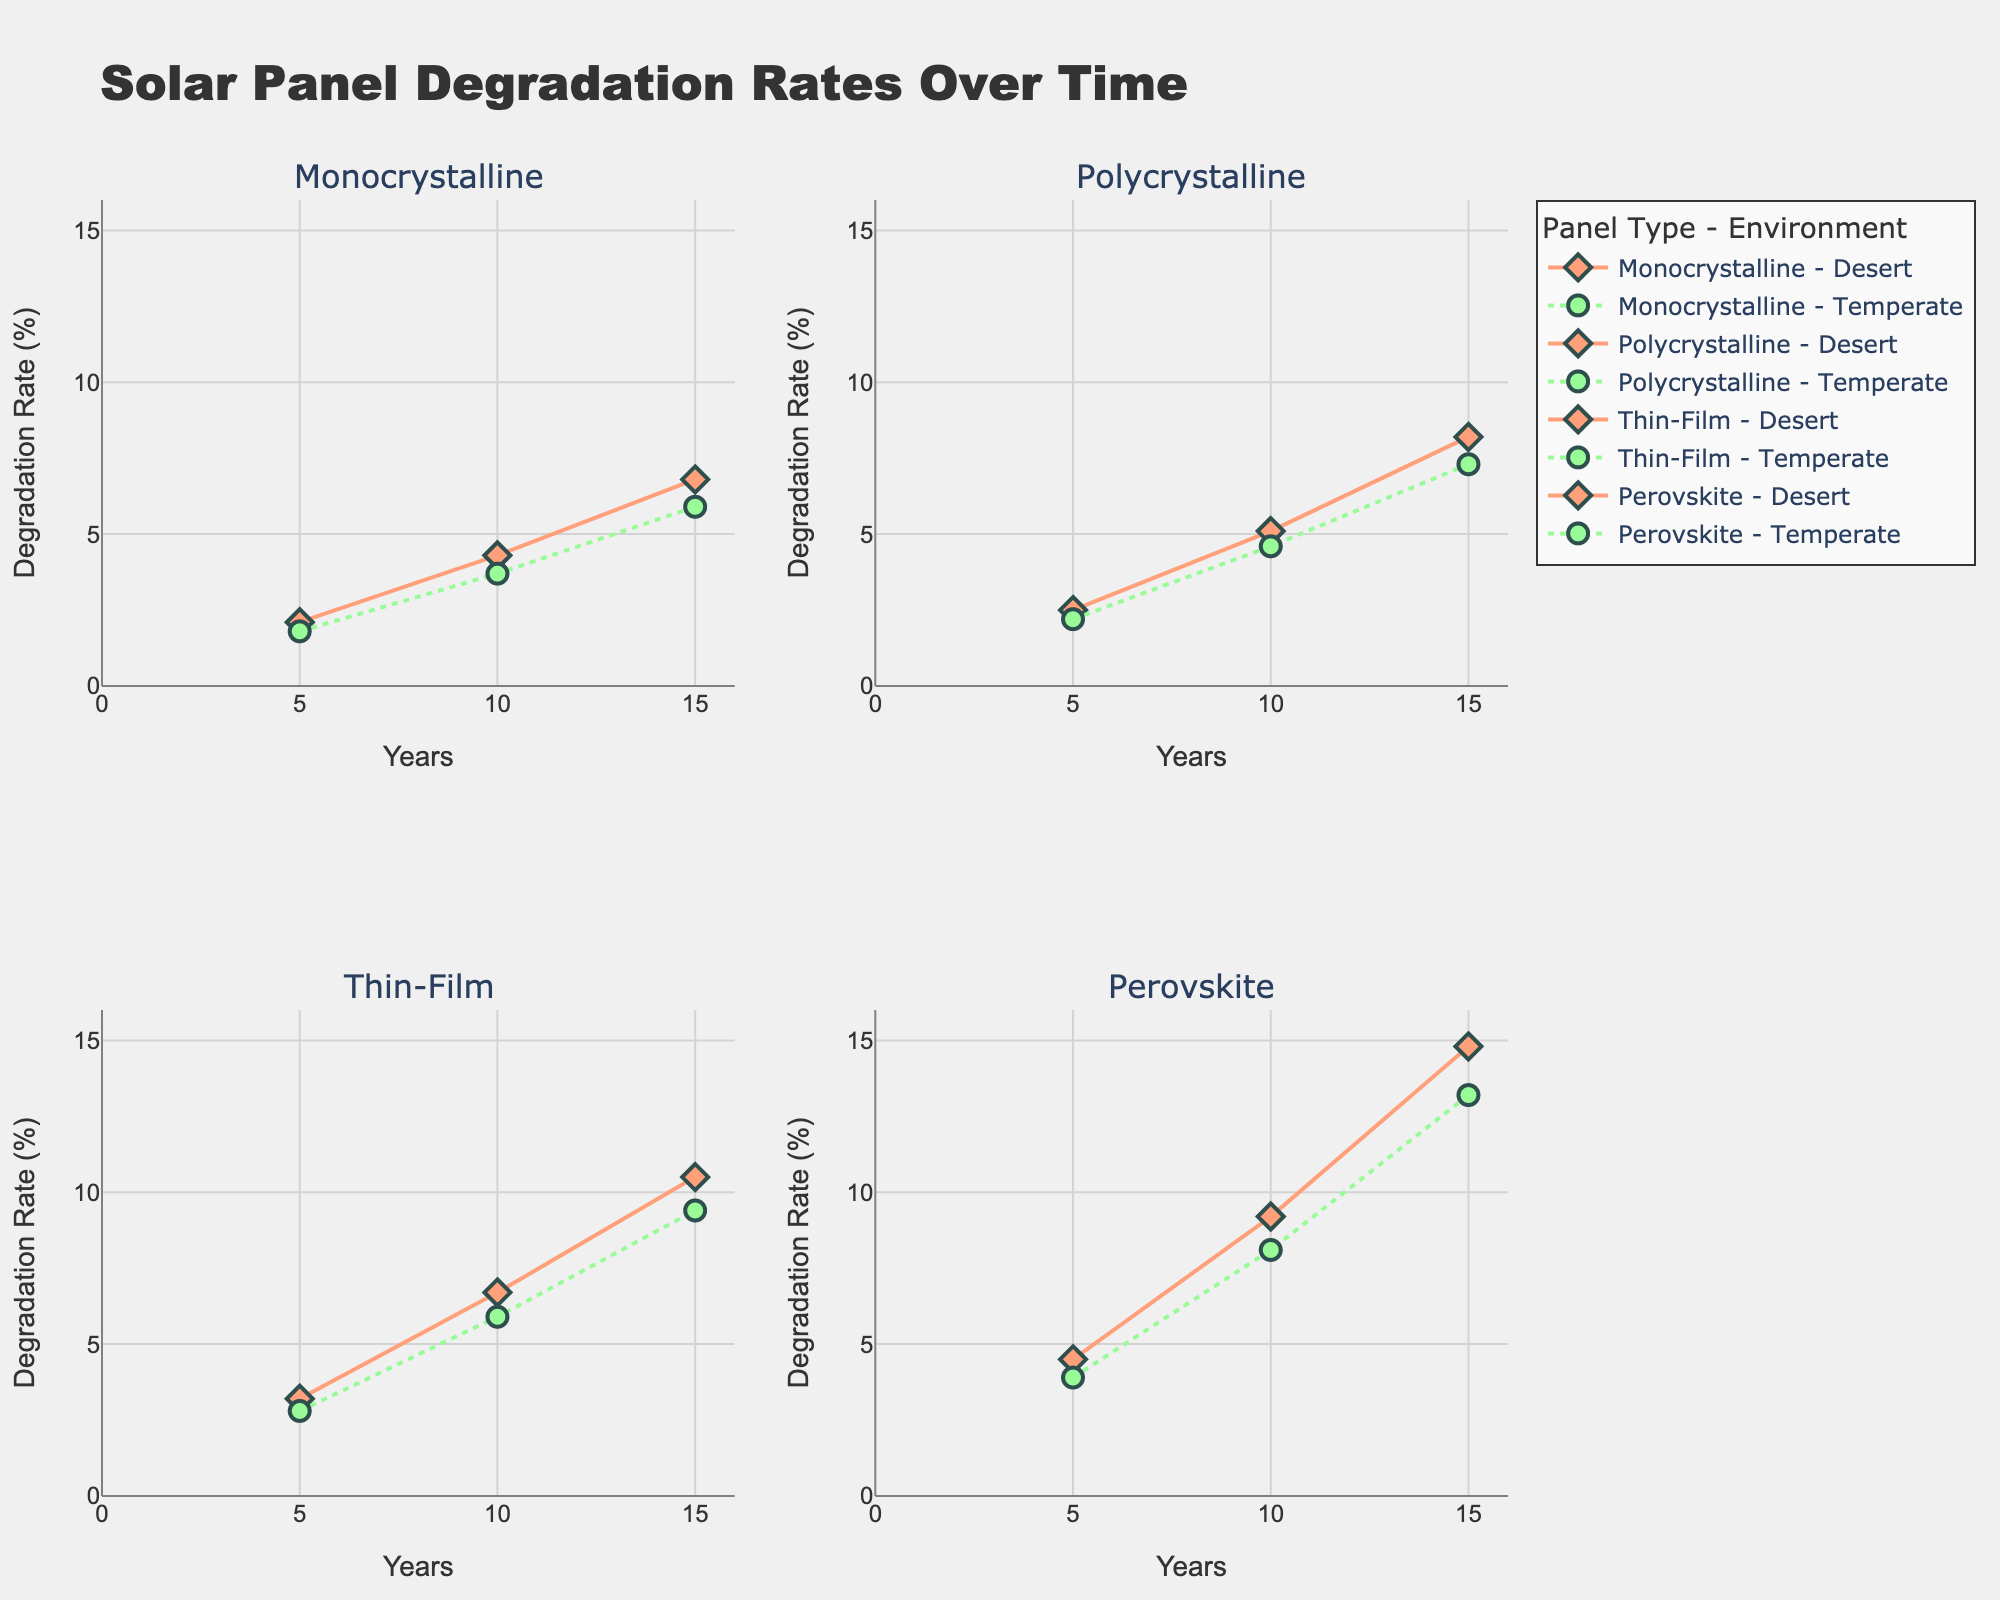What is the title of the figure? The title of the figure is displayed at the top of the plot, reading "Solar Panel Degradation Rates Over Time".
Answer: Solar Panel Degradation Rates Over Time How many types of solar panels are compared in the figure? There are four subplots within the figure, each titled with the name of a different solar panel type, implying there are four types compared: Monocrystalline, Polycrystalline, Thin-Film, and Perovskite.
Answer: Four Which environment shows a higher degradation rate for Thin-Film panels at the 10-year mark? Look at the Thin-Film subplot and compare the degradation rates for the Desert (in orange diamond markers) and Temperate (in green circle markers) for the 10-year mark. The Desert environment shows a higher rate of 6.7% compared to 5.9% in the Temperate environment.
Answer: Desert What is the degradation rate difference at the 15-year mark between Monocrystalline panels in Desert and Polycrystalline panels in Temperate environments? In their respective subplots, the degradation rates at the 15-year mark can be found: Monocrystalline in Desert is 6.8% and Polycrystalline in Temperate is 7.3%. Subtract the former from the latter to find the difference of 0.5%.
Answer: 0.5% What is the trend observed for Perovskite panels in both environments over time? Perovskite panels in both Desert and Temperate environments show an increasing trend over time in degradation rates. This is shown by the upward trends in both series of markers and lines within the Perovskite subplot.
Answer: Increasing How does the initial degradation rate (at the 5-year mark) of Monocrystalline panels in Temperate environments compare to Polycrystalline panels in Desert environments? Find and compare the degradation rates at the 5-year mark from their subplots: Monocrystalline in Temperate is 1.8% and Polycrystalline in Desert is 2.5%. The degradation rate of Polycrystalline in Desert is higher.
Answer: Polycrystalline in Desert is higher What is the average degradation rate for Thin-Film panels in Desert environments over the observed time periods? Sum the degradation rates of Thin-Film panels in Desert environments (3.2 + 6.7 + 10.5) and divide by the number of observations (3). The calculation yields (3.2 + 6.7 + 10.5)/3 = 6.8%.
Answer: 6.8% Do Perovskite panels degrade faster in Desert or Temperate environments at the 15-year mark? In the Perovskite subplot, compare the 15-year degradation rates. In Desert, it is 14.8%, and in Temperate, it is 13.2%. The Desert environment shows a faster degradation rate.
Answer: Desert Which panel type shows the least degradation in Temperate environments at the 10-year mark? In their respective subplots, examine the 10-year degradation rates in Temperate environments: Monocrystalline (3.7%), Polycrystalline (4.6%), Thin-Film (5.9%), and Perovskite (8.1%). Monocrystalline shows the least degradation.
Answer: Monocrystalline How does the degradation rate of Polycrystalline panels in Desert environments change from the 5-year mark to the 15-year mark? Look at the Polycrystalline subplot and note the degradation rates in Desert environments at 5 years (2.5%) and 15 years (8.2%). Subtract the former from the latter showing a change of 8.2% - 2.5% = 5.7%.
Answer: Increases by 5.7% 